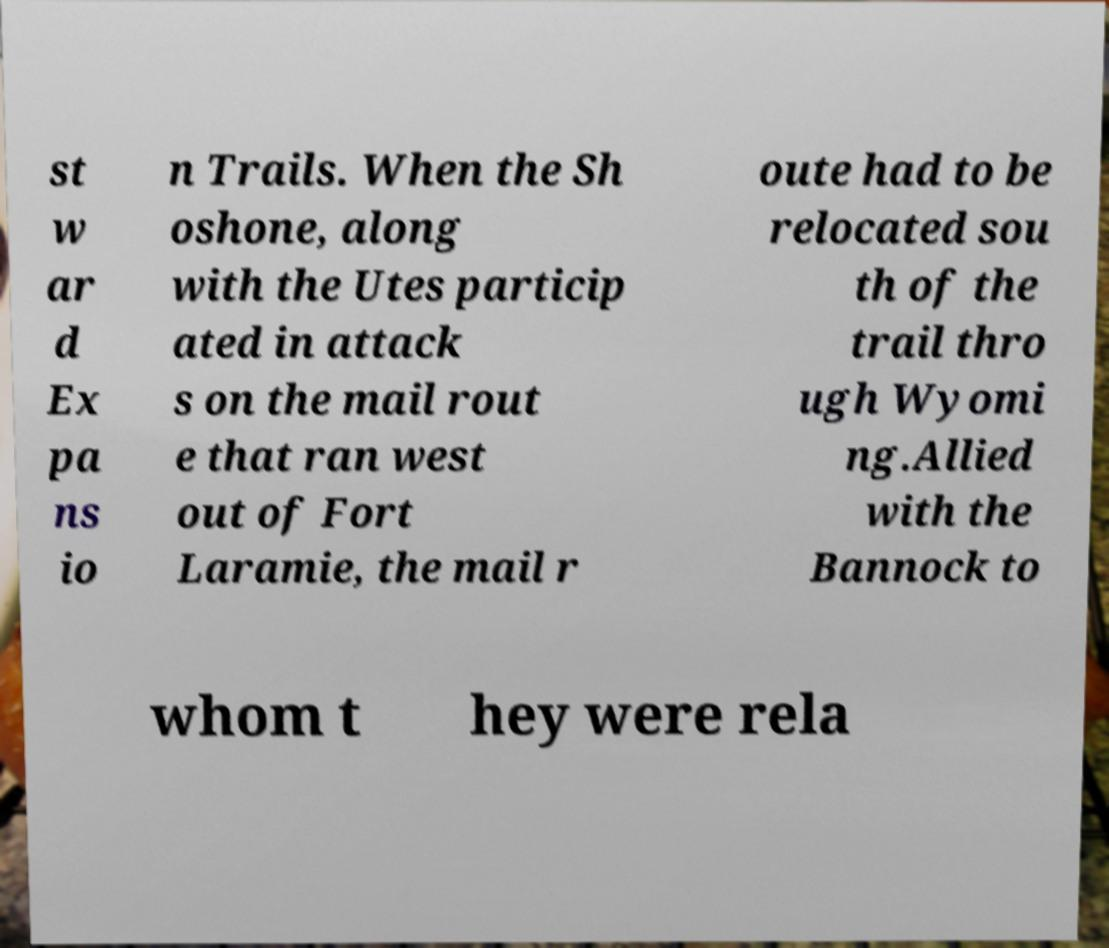For documentation purposes, I need the text within this image transcribed. Could you provide that? st w ar d Ex pa ns io n Trails. When the Sh oshone, along with the Utes particip ated in attack s on the mail rout e that ran west out of Fort Laramie, the mail r oute had to be relocated sou th of the trail thro ugh Wyomi ng.Allied with the Bannock to whom t hey were rela 